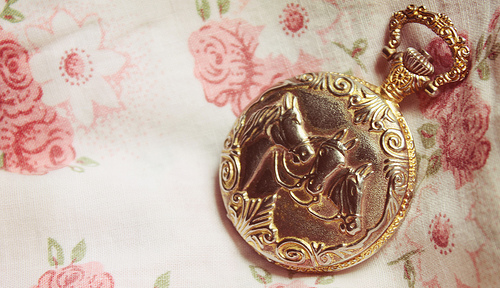<image>
Can you confirm if the gold horses is on the fabric? Yes. Looking at the image, I can see the gold horses is positioned on top of the fabric, with the fabric providing support. 